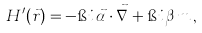Convert formula to latex. <formula><loc_0><loc_0><loc_500><loc_500>H ^ { \prime } ( \vec { r } ) = - \i i \, \vec { \alpha } \cdot \vec { \nabla } + \i i \, \beta \, m \, ,</formula> 